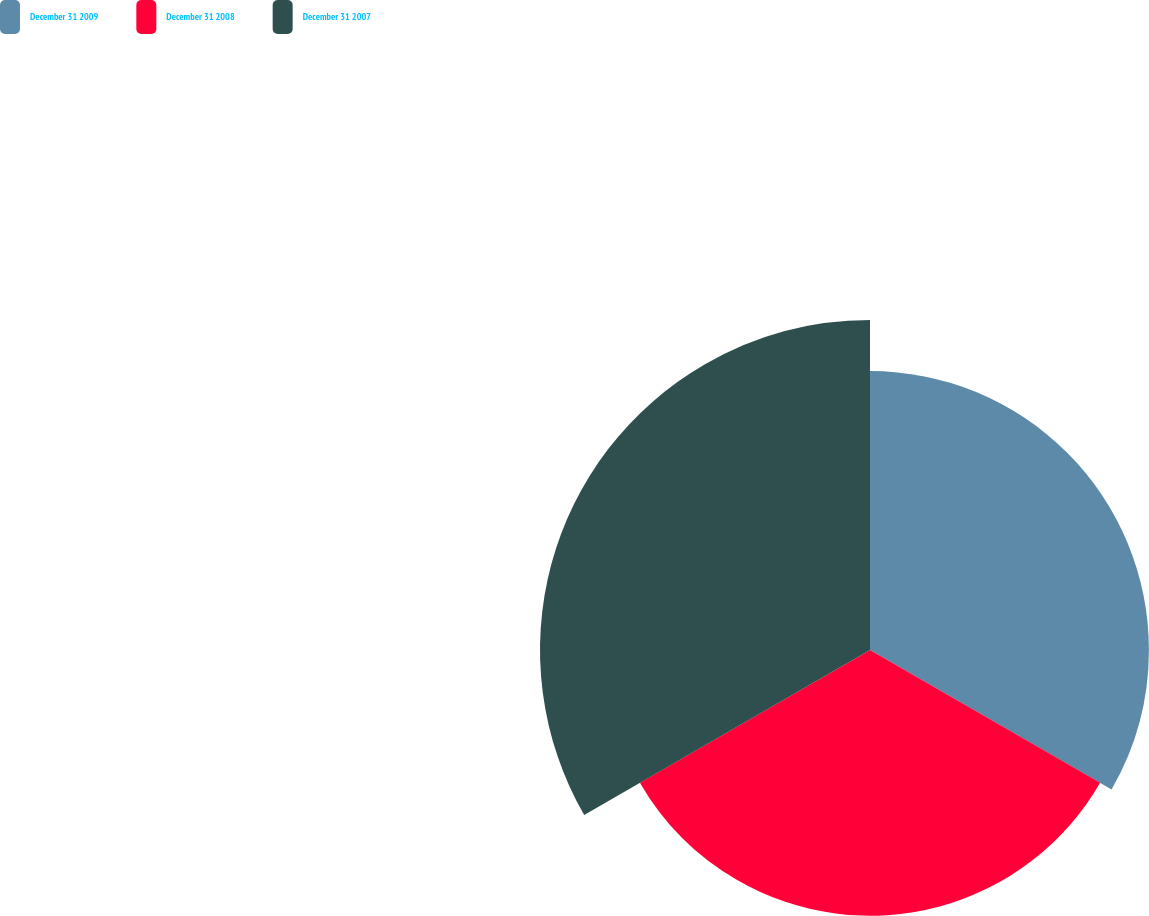Convert chart to OTSL. <chart><loc_0><loc_0><loc_500><loc_500><pie_chart><fcel>December 31 2009<fcel>December 31 2008<fcel>December 31 2007<nl><fcel>31.89%<fcel>30.38%<fcel>37.73%<nl></chart> 